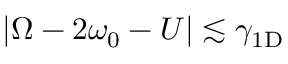<formula> <loc_0><loc_0><loc_500><loc_500>| \Omega - 2 \omega _ { 0 } - U | \lesssim \gamma _ { 1 D }</formula> 